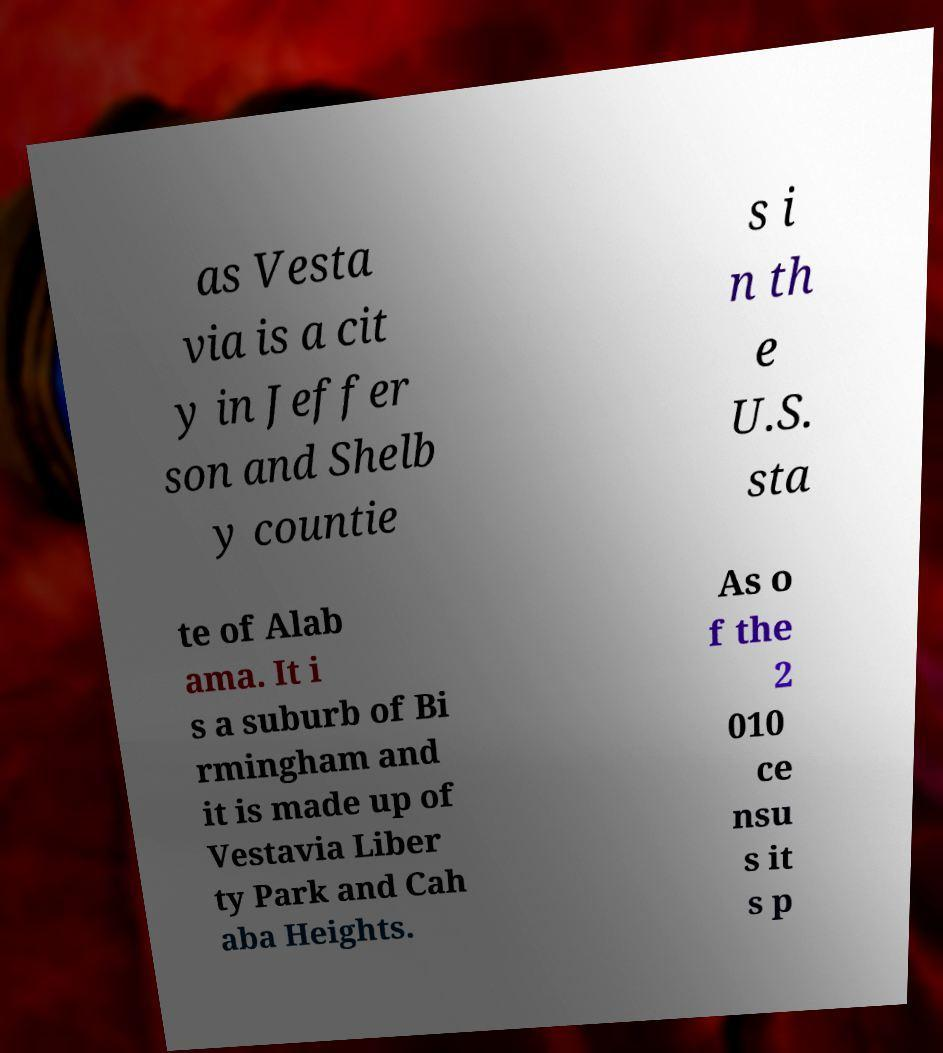Please read and relay the text visible in this image. What does it say? as Vesta via is a cit y in Jeffer son and Shelb y countie s i n th e U.S. sta te of Alab ama. It i s a suburb of Bi rmingham and it is made up of Vestavia Liber ty Park and Cah aba Heights. As o f the 2 010 ce nsu s it s p 